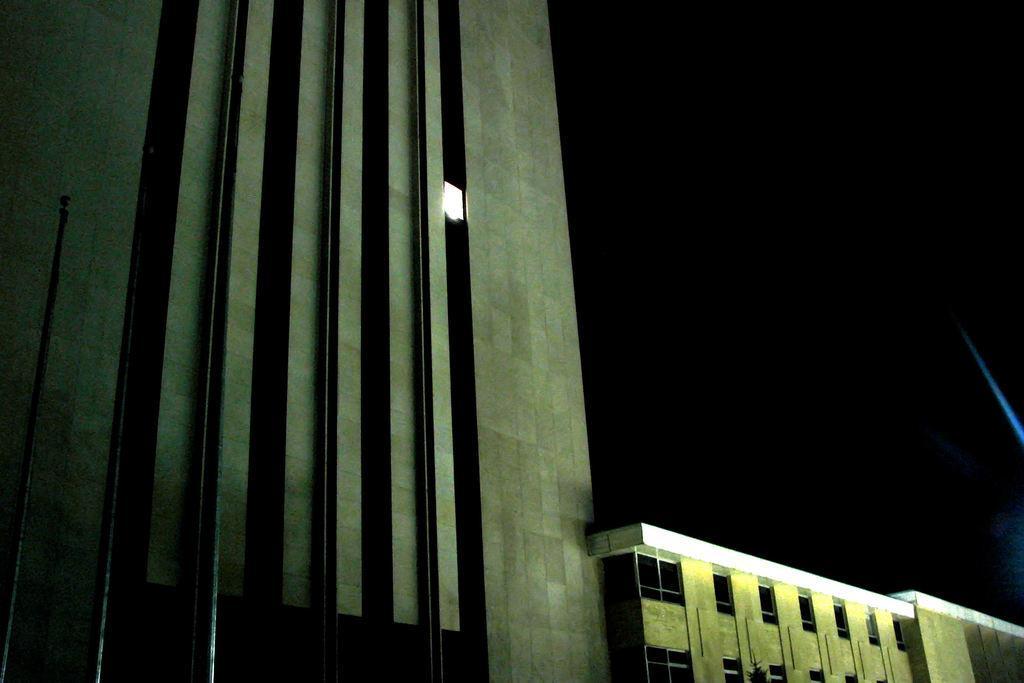How would you summarize this image in a sentence or two? In the center of the image buildings are there. At the top of the image sky is there. On the left side of the image a pole is there. 